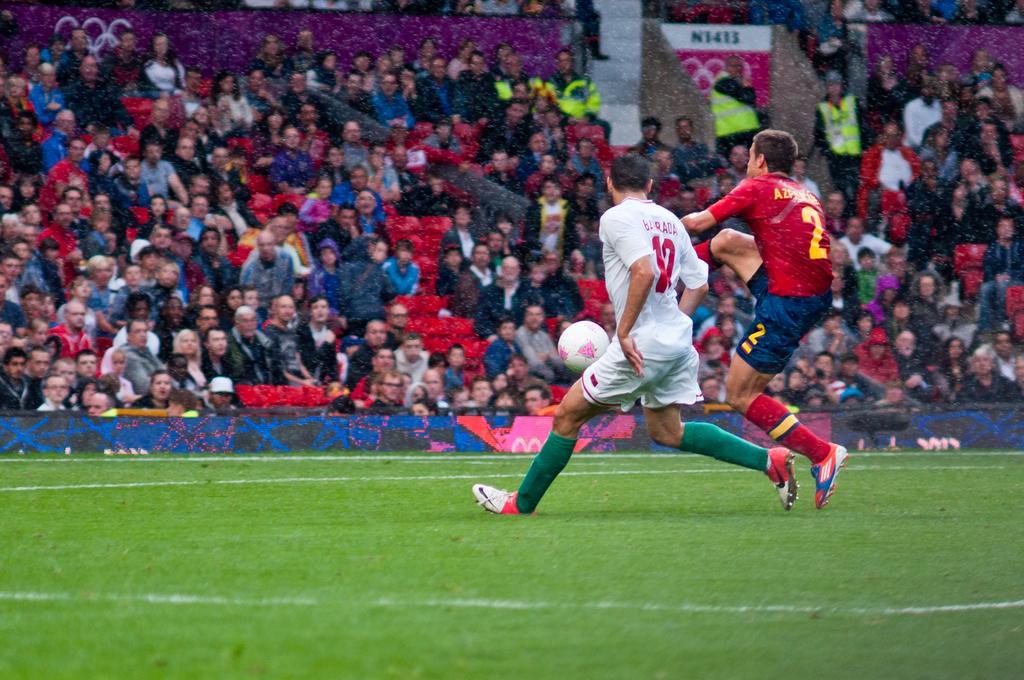Can you describe this image briefly? In the foreground I can see two persons are playing football on the ground. In the background I can see a crowd, fence and boards. This image is taken may be on the ground. 